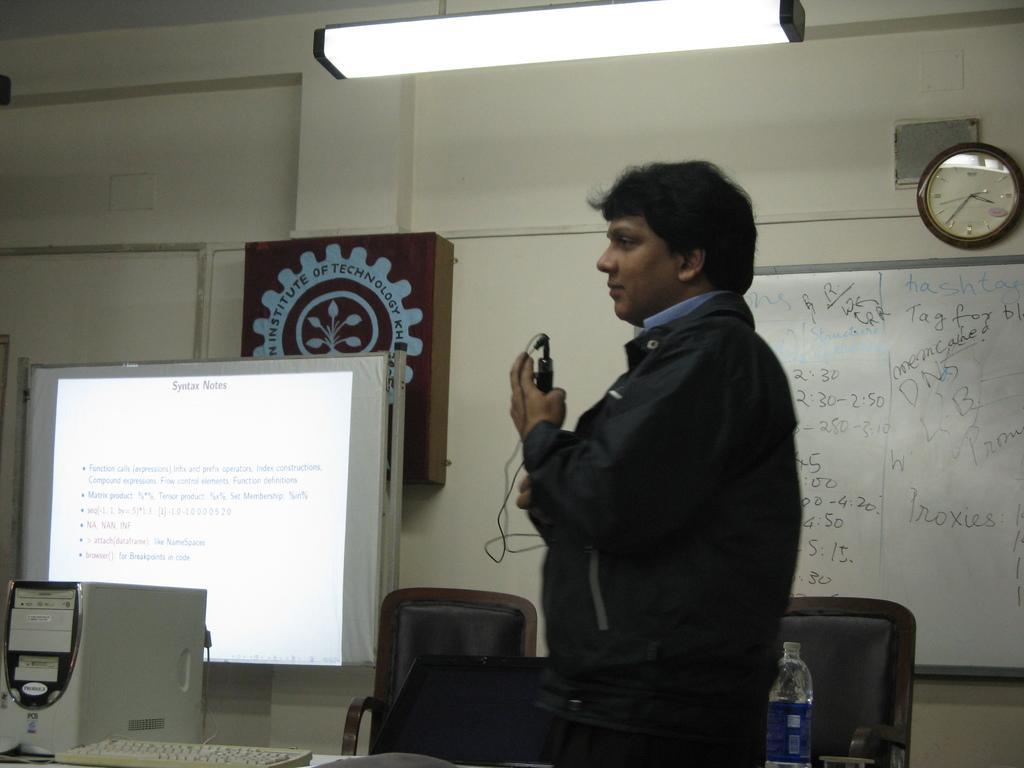How would you summarize this image in a sentence or two? In this image I can see the person is standing and holding something. Back I can see few boards, clock, screen, wall and few chairs. In front I can see the bottle, keyboard and CPU on the table. 